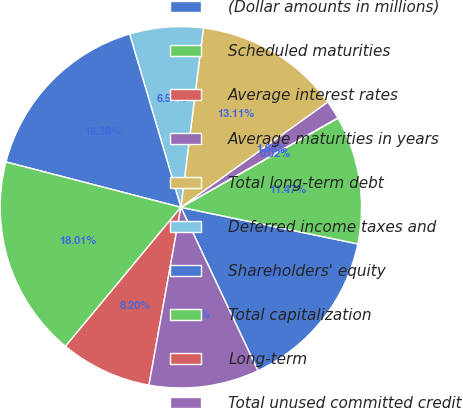<chart> <loc_0><loc_0><loc_500><loc_500><pie_chart><fcel>(Dollar amounts in millions)<fcel>Scheduled maturities<fcel>Average interest rates<fcel>Average maturities in years<fcel>Total long-term debt<fcel>Deferred income taxes and<fcel>Shareholders' equity<fcel>Total capitalization<fcel>Long-term<fcel>Total unused committed credit<nl><fcel>14.74%<fcel>11.47%<fcel>0.02%<fcel>1.66%<fcel>13.11%<fcel>6.57%<fcel>16.38%<fcel>18.01%<fcel>8.2%<fcel>9.84%<nl></chart> 